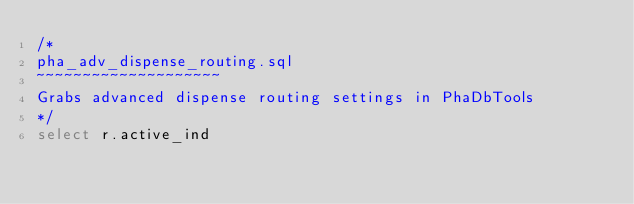Convert code to text. <code><loc_0><loc_0><loc_500><loc_500><_SQL_>/*
pha_adv_dispense_routing.sql
~~~~~~~~~~~~~~~~~~~~
Grabs advanced dispense routing settings in PhaDbTools
*/
select r.active_ind</code> 